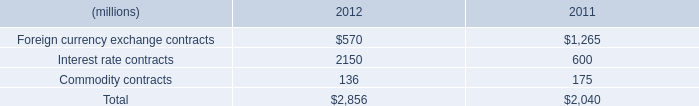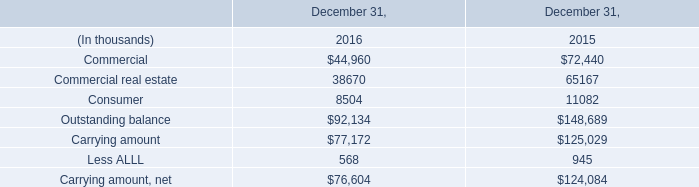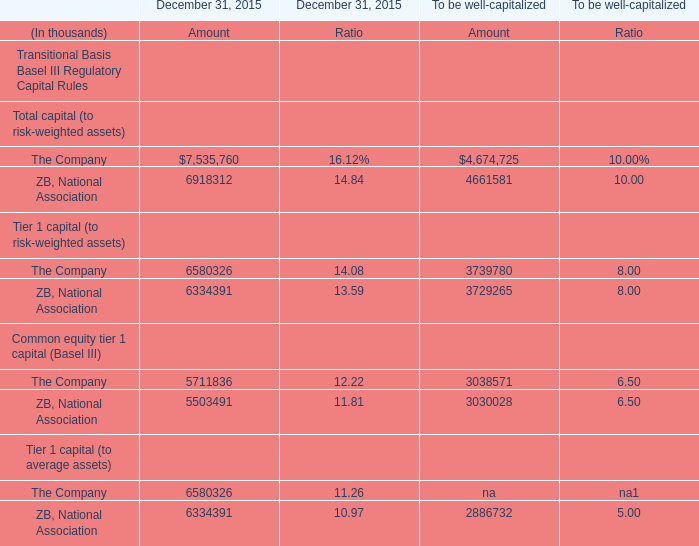what's the total amount of Interest rate contracts of 2012, The Company of December 31, 2015 Amount, and Consumer of December 31, 2016 ? 
Computations: ((2150.0 + 7535760.0) + 8504.0)
Answer: 7546414.0. 